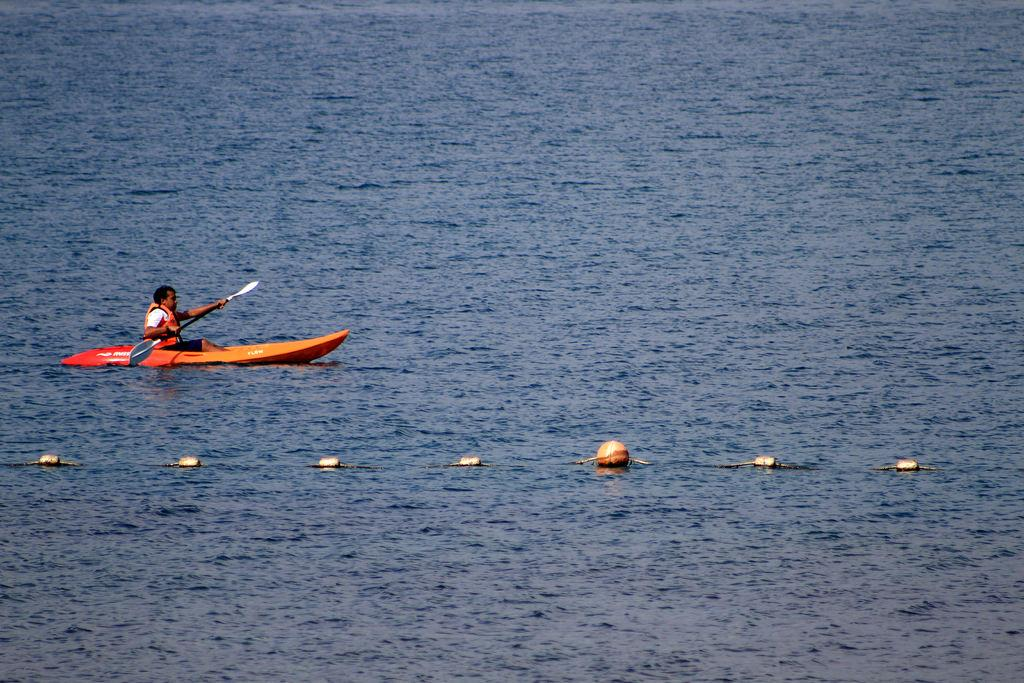Who is present in the image? There is a person in the image. What is the person doing in the image? The person is in a boat. Where is the boat located in the image? The boat is sailing on a river. What type of government is depicted in the image? There is no government depicted in the image; it features a person in a boat sailing on a river. What kind of fruit is the person holding in the image? There is no fruit present in the image; it only shows a person in a boat sailing on a river. 